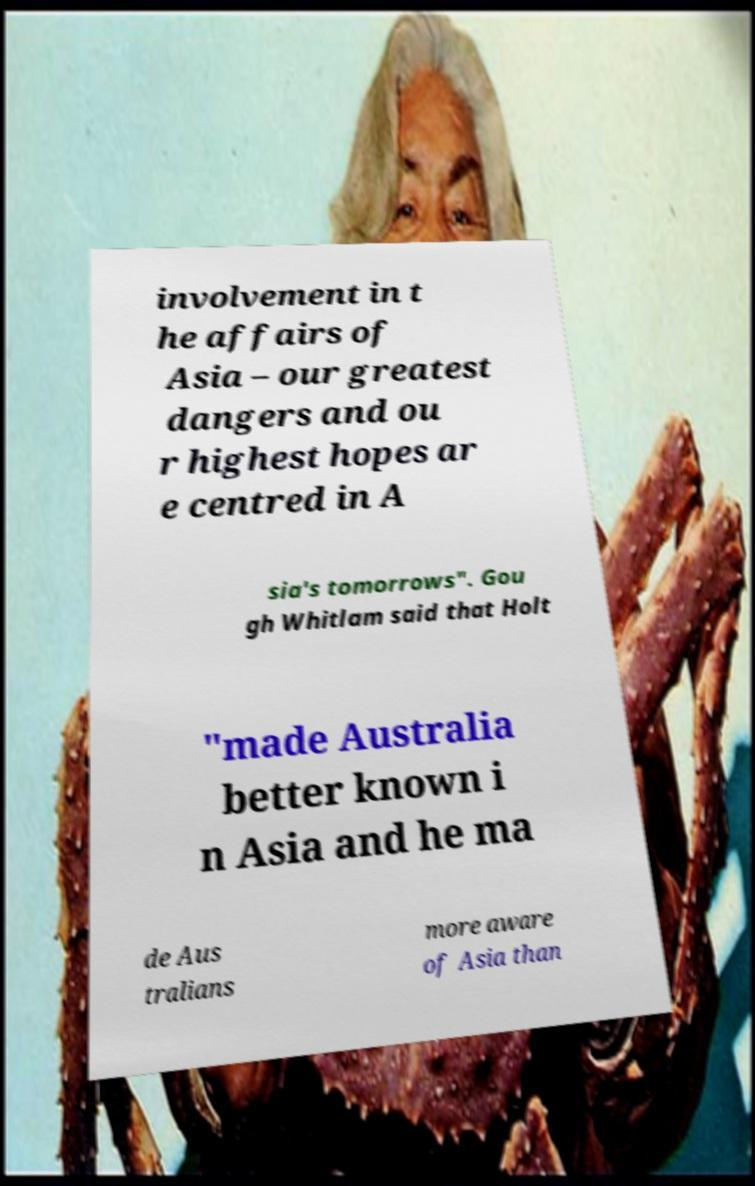Can you accurately transcribe the text from the provided image for me? involvement in t he affairs of Asia – our greatest dangers and ou r highest hopes ar e centred in A sia's tomorrows". Gou gh Whitlam said that Holt "made Australia better known i n Asia and he ma de Aus tralians more aware of Asia than 